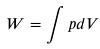Convert formula to latex. <formula><loc_0><loc_0><loc_500><loc_500>W = \int p d V</formula> 